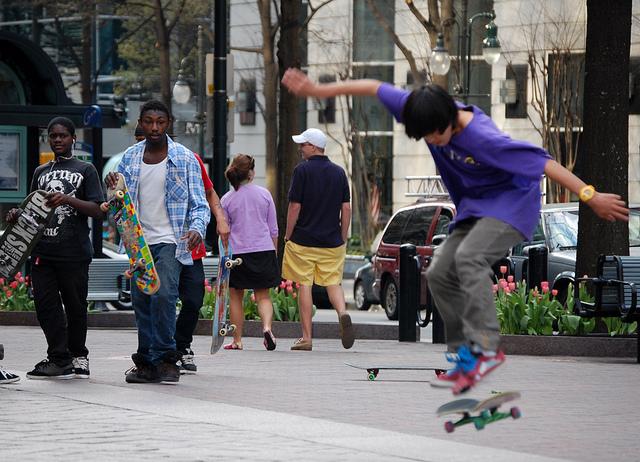Is there blood on the street?
Write a very short answer. No. Is the man in purple flying above his board?
Answer briefly. Yes. What kind of skateboard is he riding?
Keep it brief. Wooden. Is this in a park?
Write a very short answer. No. Will the skateboarder fall on the boy with the blue shirt?
Concise answer only. No. What does the text on the skateboard say?
Give a very brief answer. Black sheep. What type of shoe is the woman wearing?
Write a very short answer. Sandals. What are the guys holding?
Give a very brief answer. Skateboards. How many men are touching their faces?
Quick response, please. 0. 